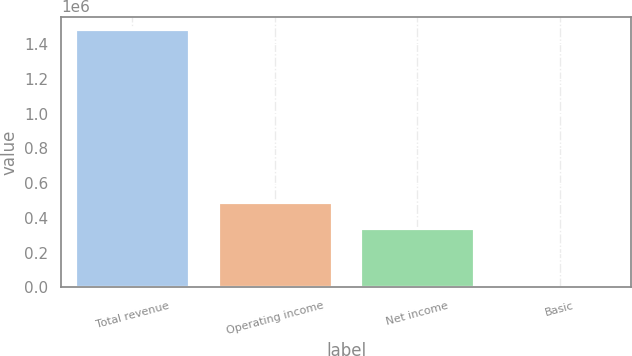<chart> <loc_0><loc_0><loc_500><loc_500><bar_chart><fcel>Total revenue<fcel>Operating income<fcel>Net income<fcel>Basic<nl><fcel>1.48474e+06<fcel>490851<fcel>342378<fcel>1.51<nl></chart> 